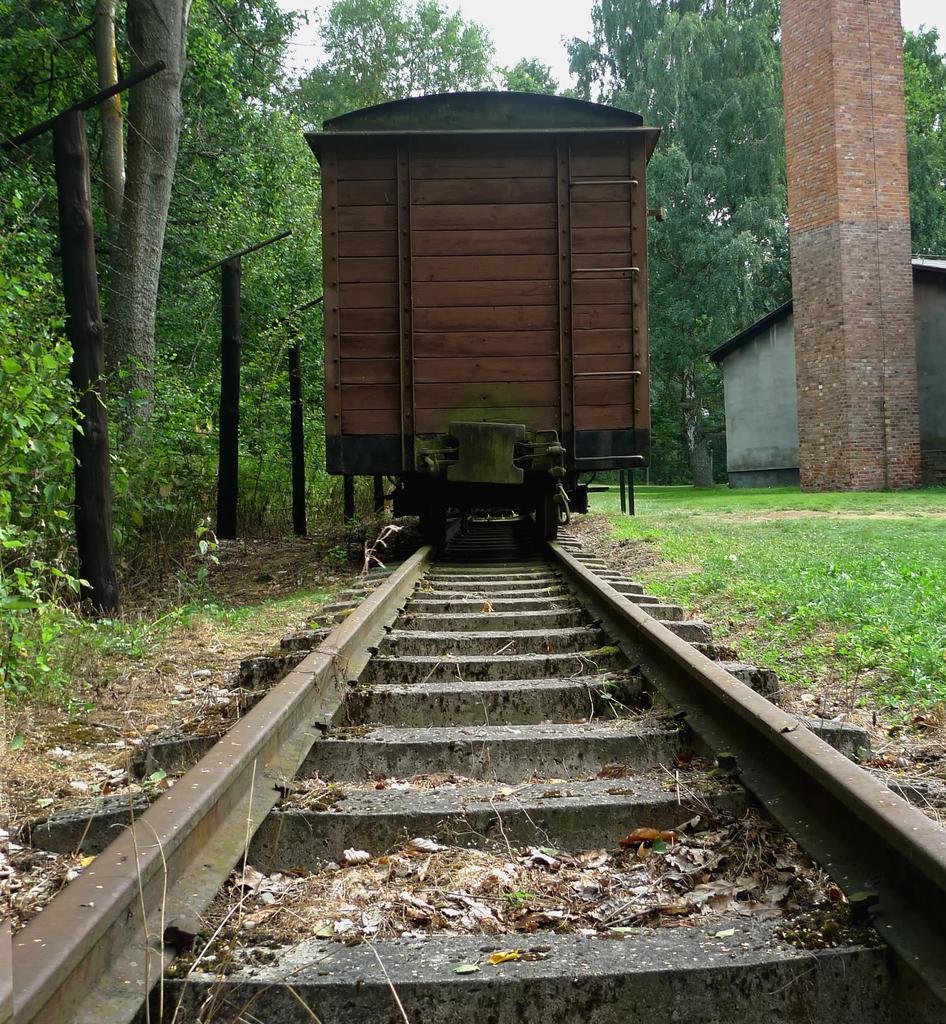In one or two sentences, can you explain what this image depicts? In the image there is a railway track in the foreground, on the railway track there is a train and around the train there is grass, a pillar, house and trees. 